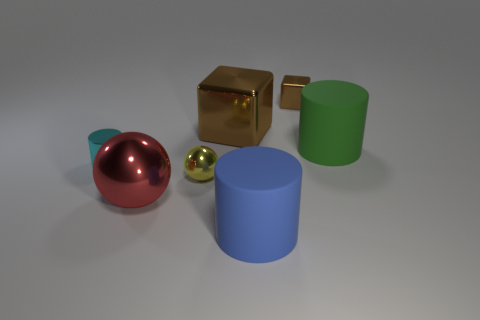Subtract all big cylinders. How many cylinders are left? 1 Subtract all green cylinders. How many cylinders are left? 2 Subtract all spheres. How many objects are left? 5 Subtract 2 cylinders. How many cylinders are left? 1 Subtract all yellow spheres. How many brown cylinders are left? 0 Add 1 tiny metal objects. How many tiny metal objects are left? 4 Add 2 large brown metal objects. How many large brown metal objects exist? 3 Add 1 green rubber cylinders. How many objects exist? 8 Subtract 0 purple blocks. How many objects are left? 7 Subtract all cyan cylinders. Subtract all purple balls. How many cylinders are left? 2 